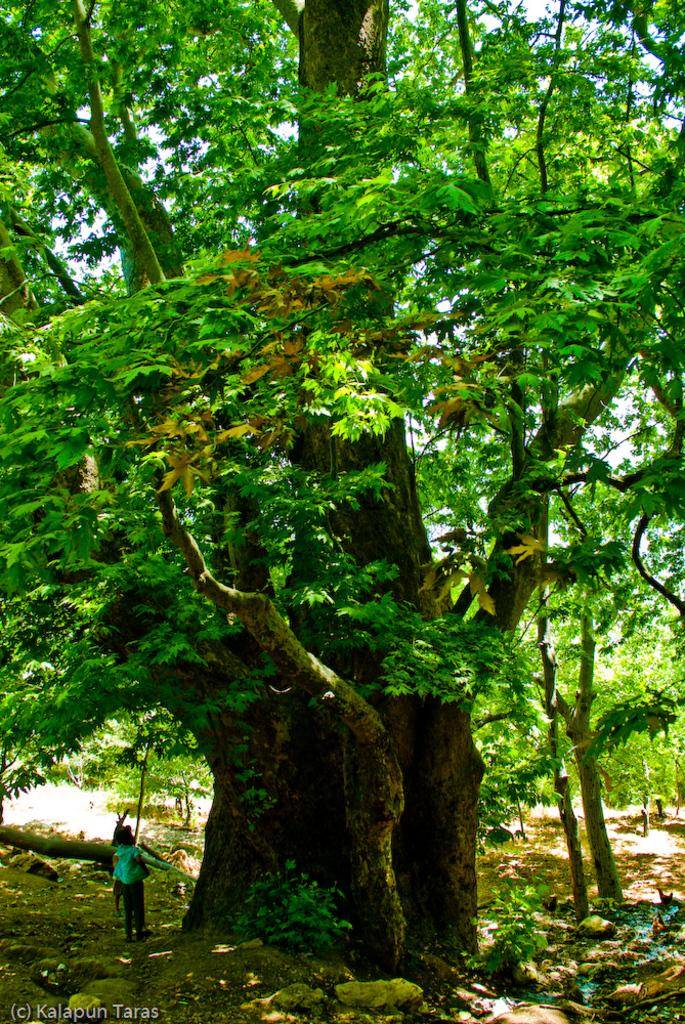How many people are in the image? There are two people in the image. Where are the two people standing? The two people are standing under a huge tree. What can be seen in the background of the image? There are many trees visible in the background. What is the condition of the land in the image? The land has stones on it. What type of structure can be seen in the image? There is no structure present in the image; it features two people standing under a tree on a stony land. What type of stitch is being used by the person on the left in the image? There is no person sewing or using a stitch in the image; it only shows two people standing under a tree. 